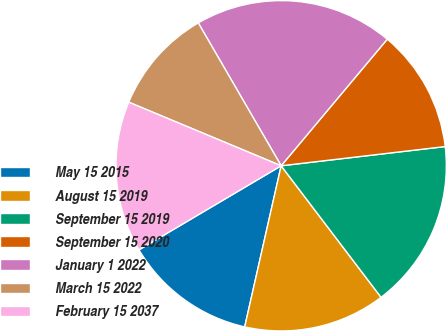<chart> <loc_0><loc_0><loc_500><loc_500><pie_chart><fcel>May 15 2015<fcel>August 15 2019<fcel>September 15 2019<fcel>September 15 2020<fcel>January 1 2022<fcel>March 15 2022<fcel>February 15 2037<nl><fcel>12.96%<fcel>13.88%<fcel>16.52%<fcel>12.04%<fcel>19.47%<fcel>10.34%<fcel>14.79%<nl></chart> 